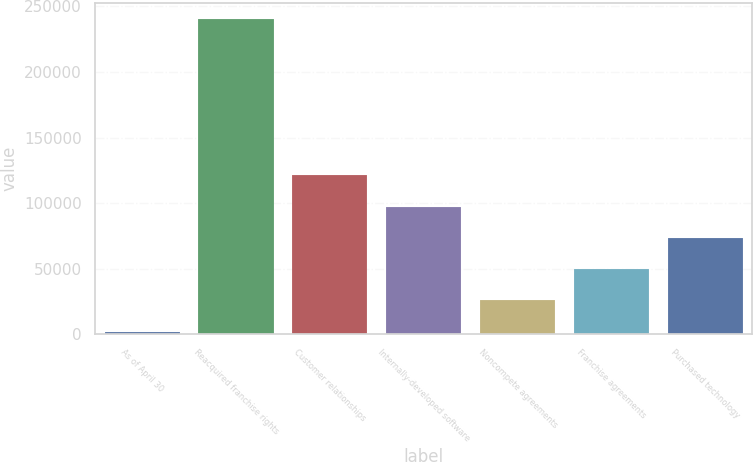Convert chart. <chart><loc_0><loc_0><loc_500><loc_500><bar_chart><fcel>As of April 30<fcel>Reacquired franchise rights<fcel>Customer relationships<fcel>Internally-developed software<fcel>Noncompete agreements<fcel>Franchise agreements<fcel>Purchased technology<nl><fcel>2017<fcel>240273<fcel>121145<fcel>97319.4<fcel>25842.6<fcel>49668.2<fcel>73493.8<nl></chart> 